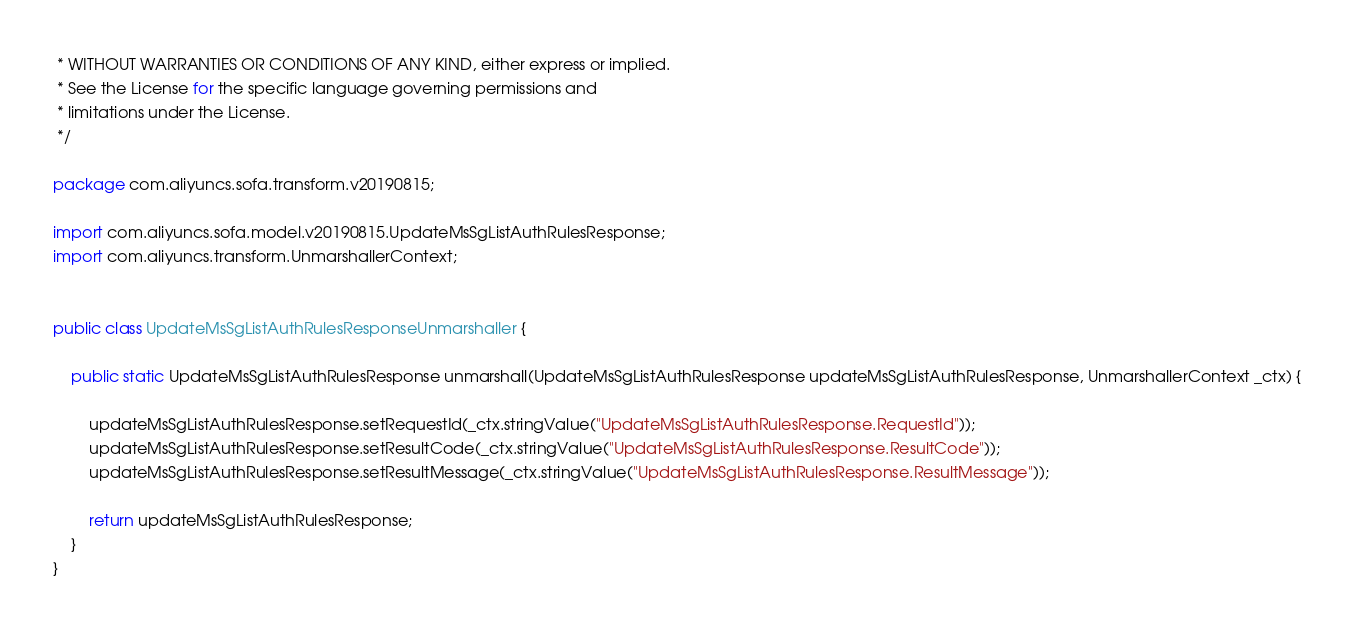Convert code to text. <code><loc_0><loc_0><loc_500><loc_500><_Java_> * WITHOUT WARRANTIES OR CONDITIONS OF ANY KIND, either express or implied.
 * See the License for the specific language governing permissions and
 * limitations under the License.
 */

package com.aliyuncs.sofa.transform.v20190815;

import com.aliyuncs.sofa.model.v20190815.UpdateMsSgListAuthRulesResponse;
import com.aliyuncs.transform.UnmarshallerContext;


public class UpdateMsSgListAuthRulesResponseUnmarshaller {

	public static UpdateMsSgListAuthRulesResponse unmarshall(UpdateMsSgListAuthRulesResponse updateMsSgListAuthRulesResponse, UnmarshallerContext _ctx) {
		
		updateMsSgListAuthRulesResponse.setRequestId(_ctx.stringValue("UpdateMsSgListAuthRulesResponse.RequestId"));
		updateMsSgListAuthRulesResponse.setResultCode(_ctx.stringValue("UpdateMsSgListAuthRulesResponse.ResultCode"));
		updateMsSgListAuthRulesResponse.setResultMessage(_ctx.stringValue("UpdateMsSgListAuthRulesResponse.ResultMessage"));
	 
	 	return updateMsSgListAuthRulesResponse;
	}
}</code> 